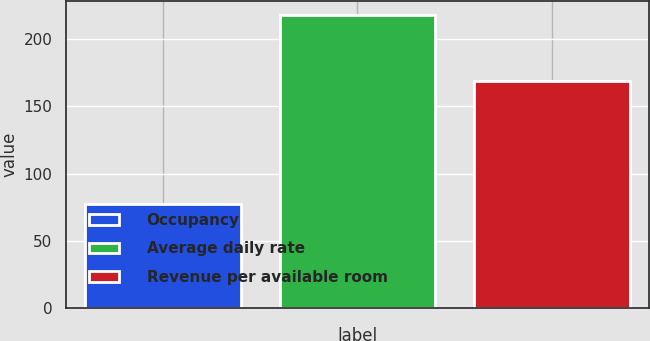Convert chart to OTSL. <chart><loc_0><loc_0><loc_500><loc_500><bar_chart><fcel>Occupancy<fcel>Average daily rate<fcel>Revenue per available room<nl><fcel>77.7<fcel>217.7<fcel>169.08<nl></chart> 